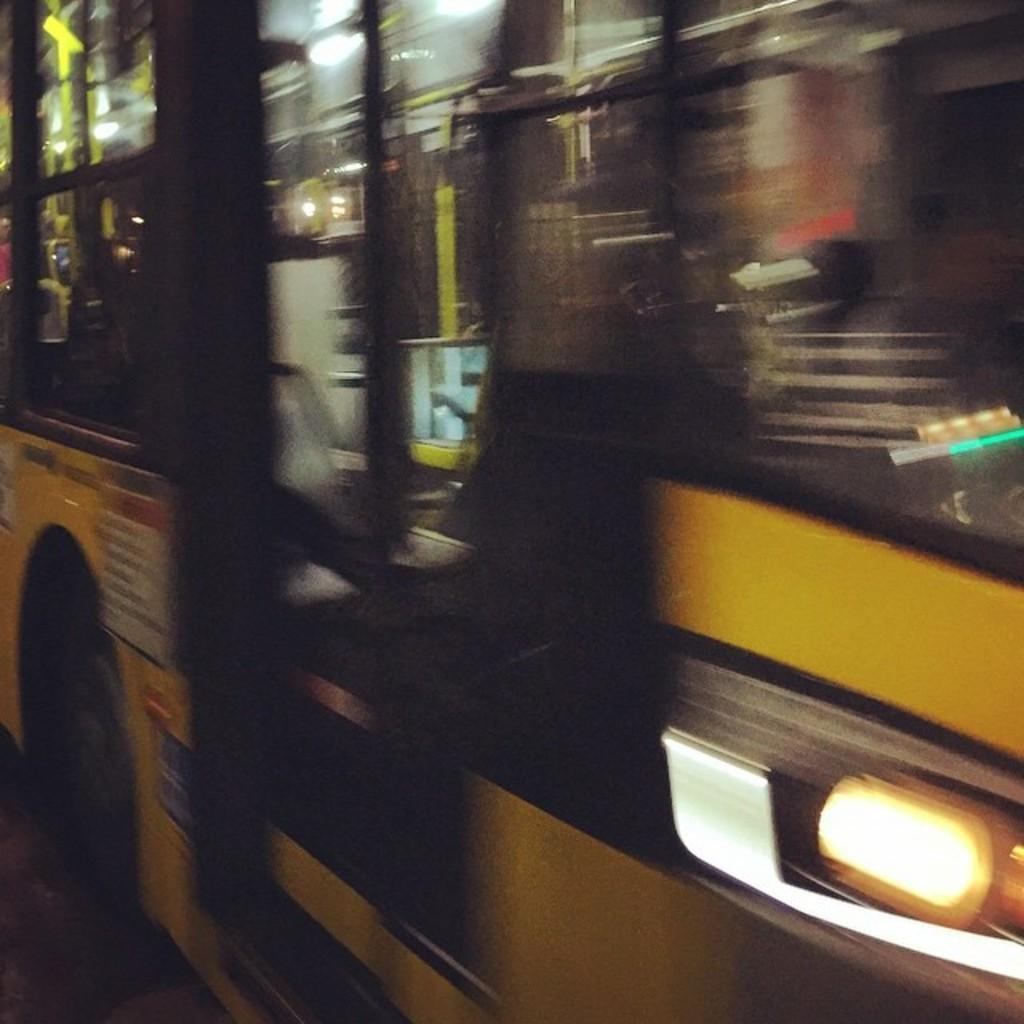What is the main subject of the image? There is a bus in the image. What else can be seen on the road in the image? There is a light on the road in the image. Can you tell if the image was taken during the day or night? The image may have been taken during the night, as there is a light on the road. How many tickets are visible on the floor in the image? There is no mention of tickets or a floor in the image, so it is not possible to answer this question. 